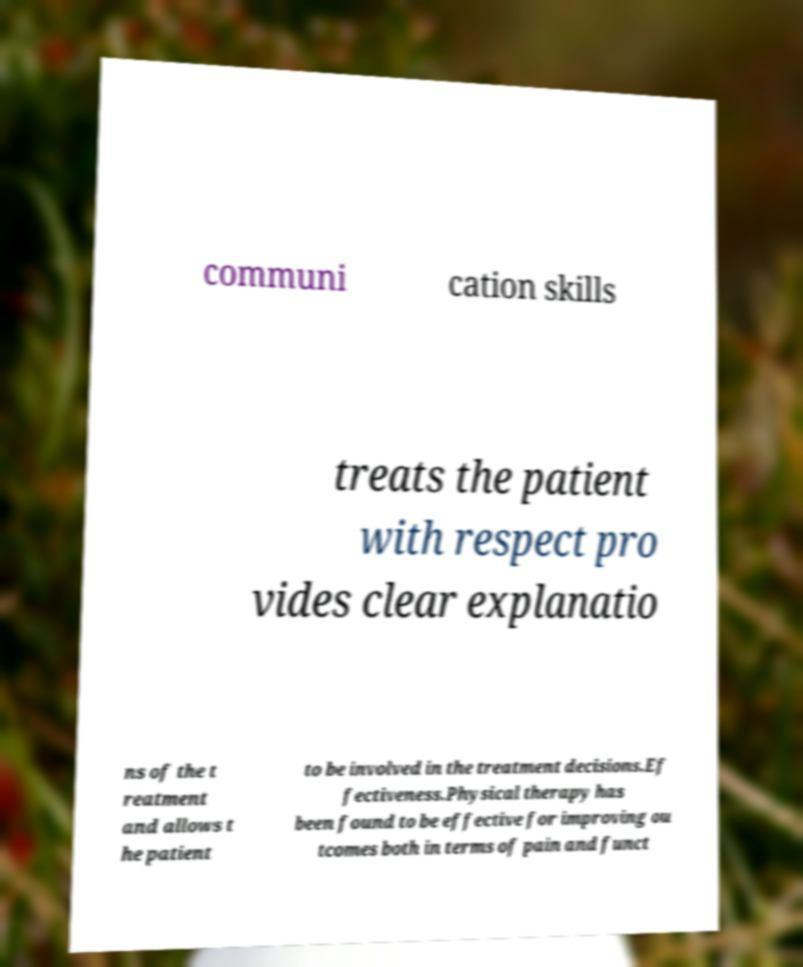There's text embedded in this image that I need extracted. Can you transcribe it verbatim? communi cation skills treats the patient with respect pro vides clear explanatio ns of the t reatment and allows t he patient to be involved in the treatment decisions.Ef fectiveness.Physical therapy has been found to be effective for improving ou tcomes both in terms of pain and funct 